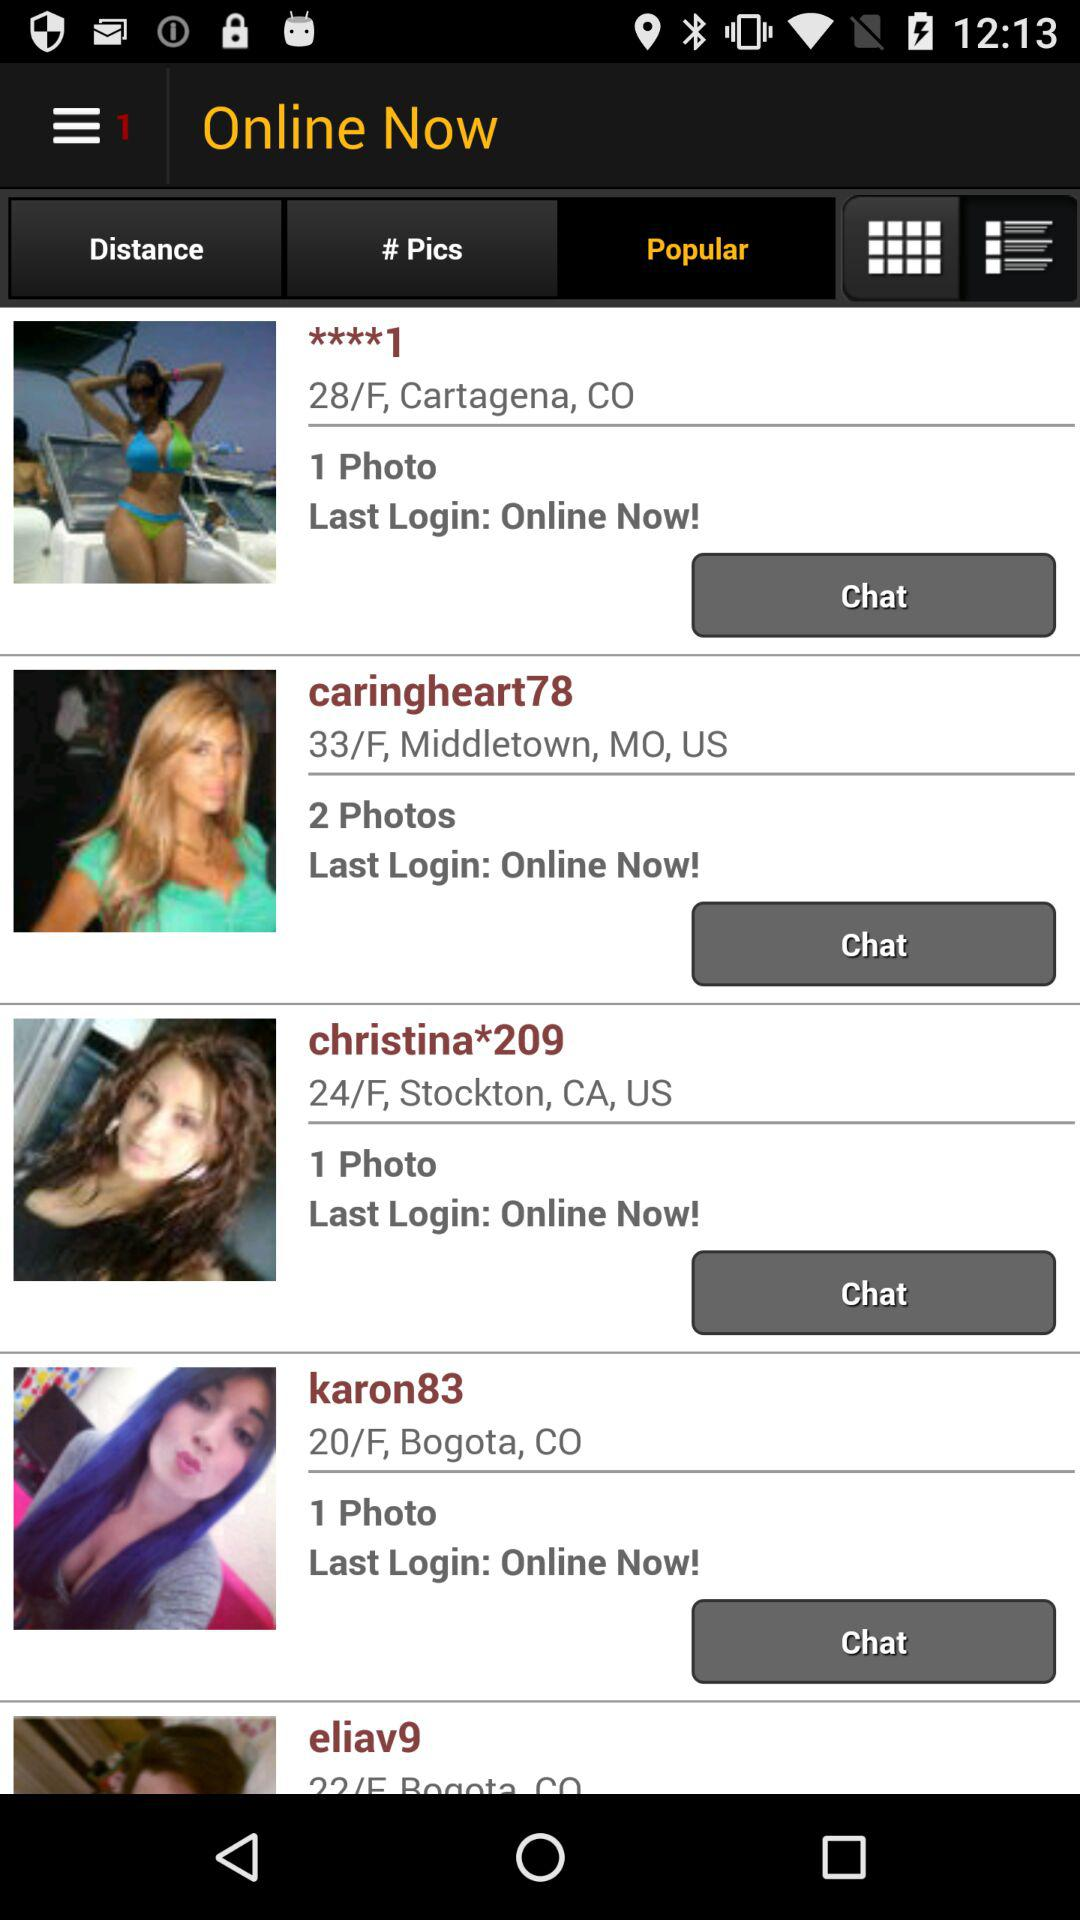How many photos does the person with the username 'caringheart78' have?
Answer the question using a single word or phrase. 2 